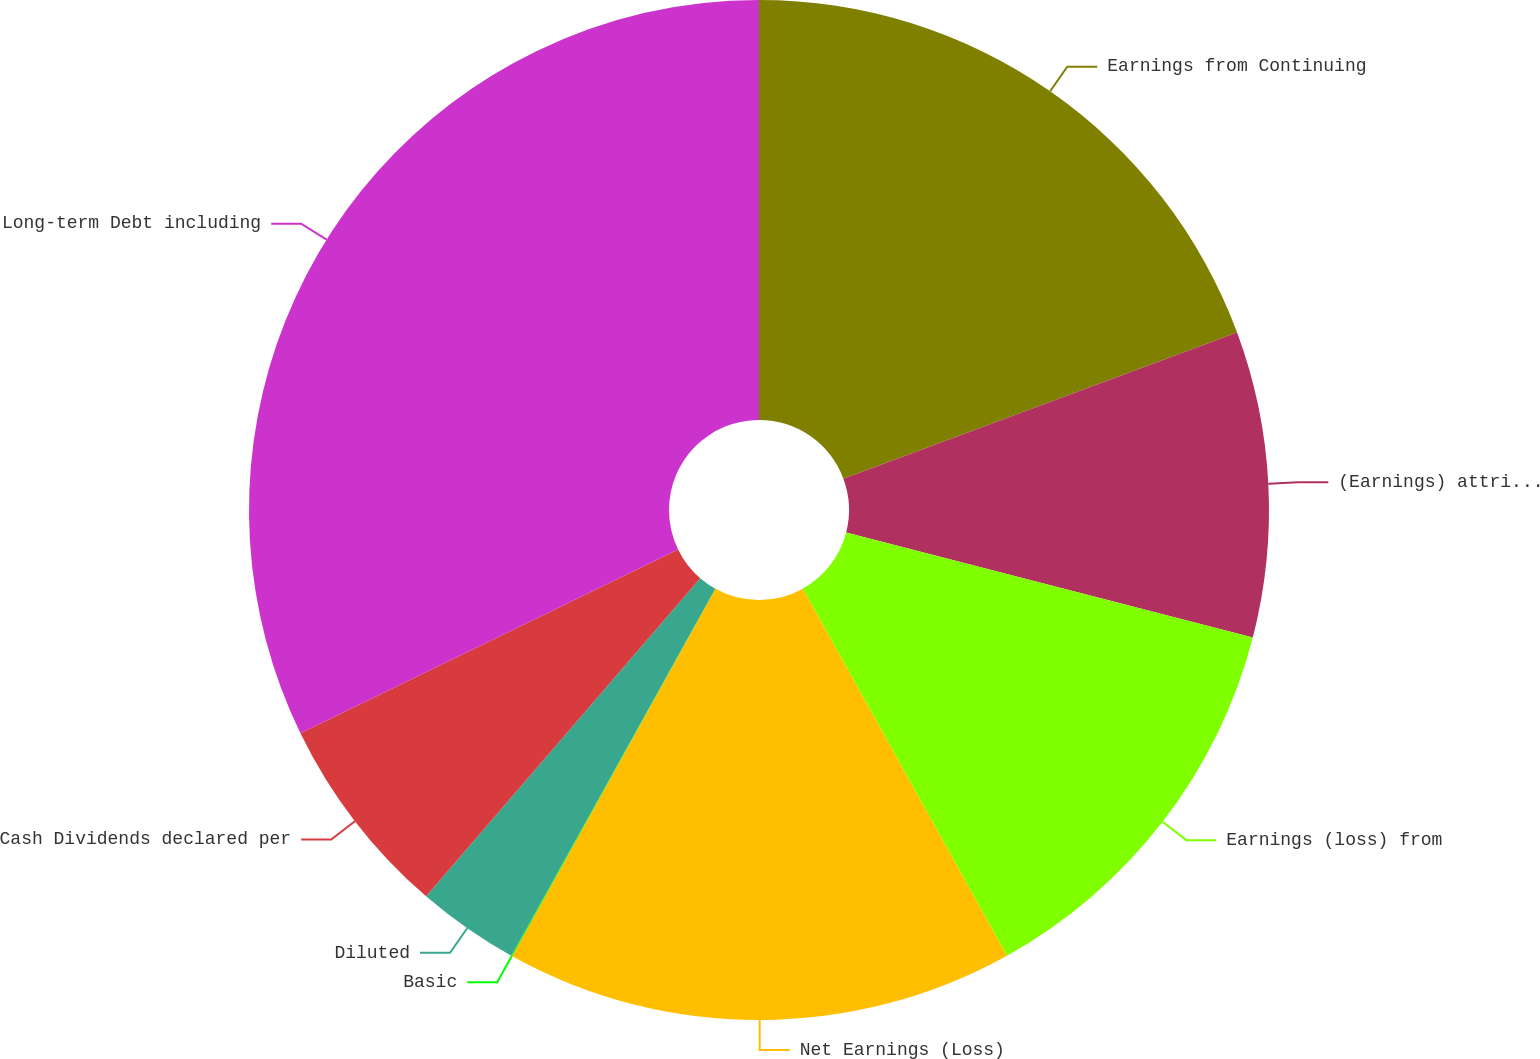<chart> <loc_0><loc_0><loc_500><loc_500><pie_chart><fcel>Earnings from Continuing<fcel>(Earnings) attributable to<fcel>Earnings (loss) from<fcel>Net Earnings (Loss)<fcel>Basic<fcel>Diluted<fcel>Cash Dividends declared per<fcel>Long-term Debt including<nl><fcel>19.34%<fcel>9.68%<fcel>12.9%<fcel>16.12%<fcel>0.03%<fcel>3.25%<fcel>6.47%<fcel>32.21%<nl></chart> 